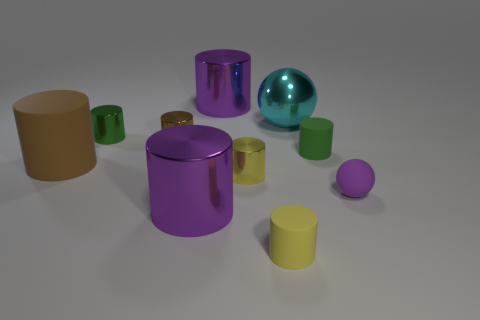Subtract 2 cylinders. How many cylinders are left? 6 Subtract all purple cylinders. How many cylinders are left? 6 Subtract all brown rubber cylinders. How many cylinders are left? 7 Subtract all brown cylinders. Subtract all gray blocks. How many cylinders are left? 6 Subtract all cylinders. How many objects are left? 2 Add 3 small things. How many small things exist? 9 Subtract 0 brown blocks. How many objects are left? 10 Subtract all tiny green cylinders. Subtract all metallic things. How many objects are left? 2 Add 3 big cyan things. How many big cyan things are left? 4 